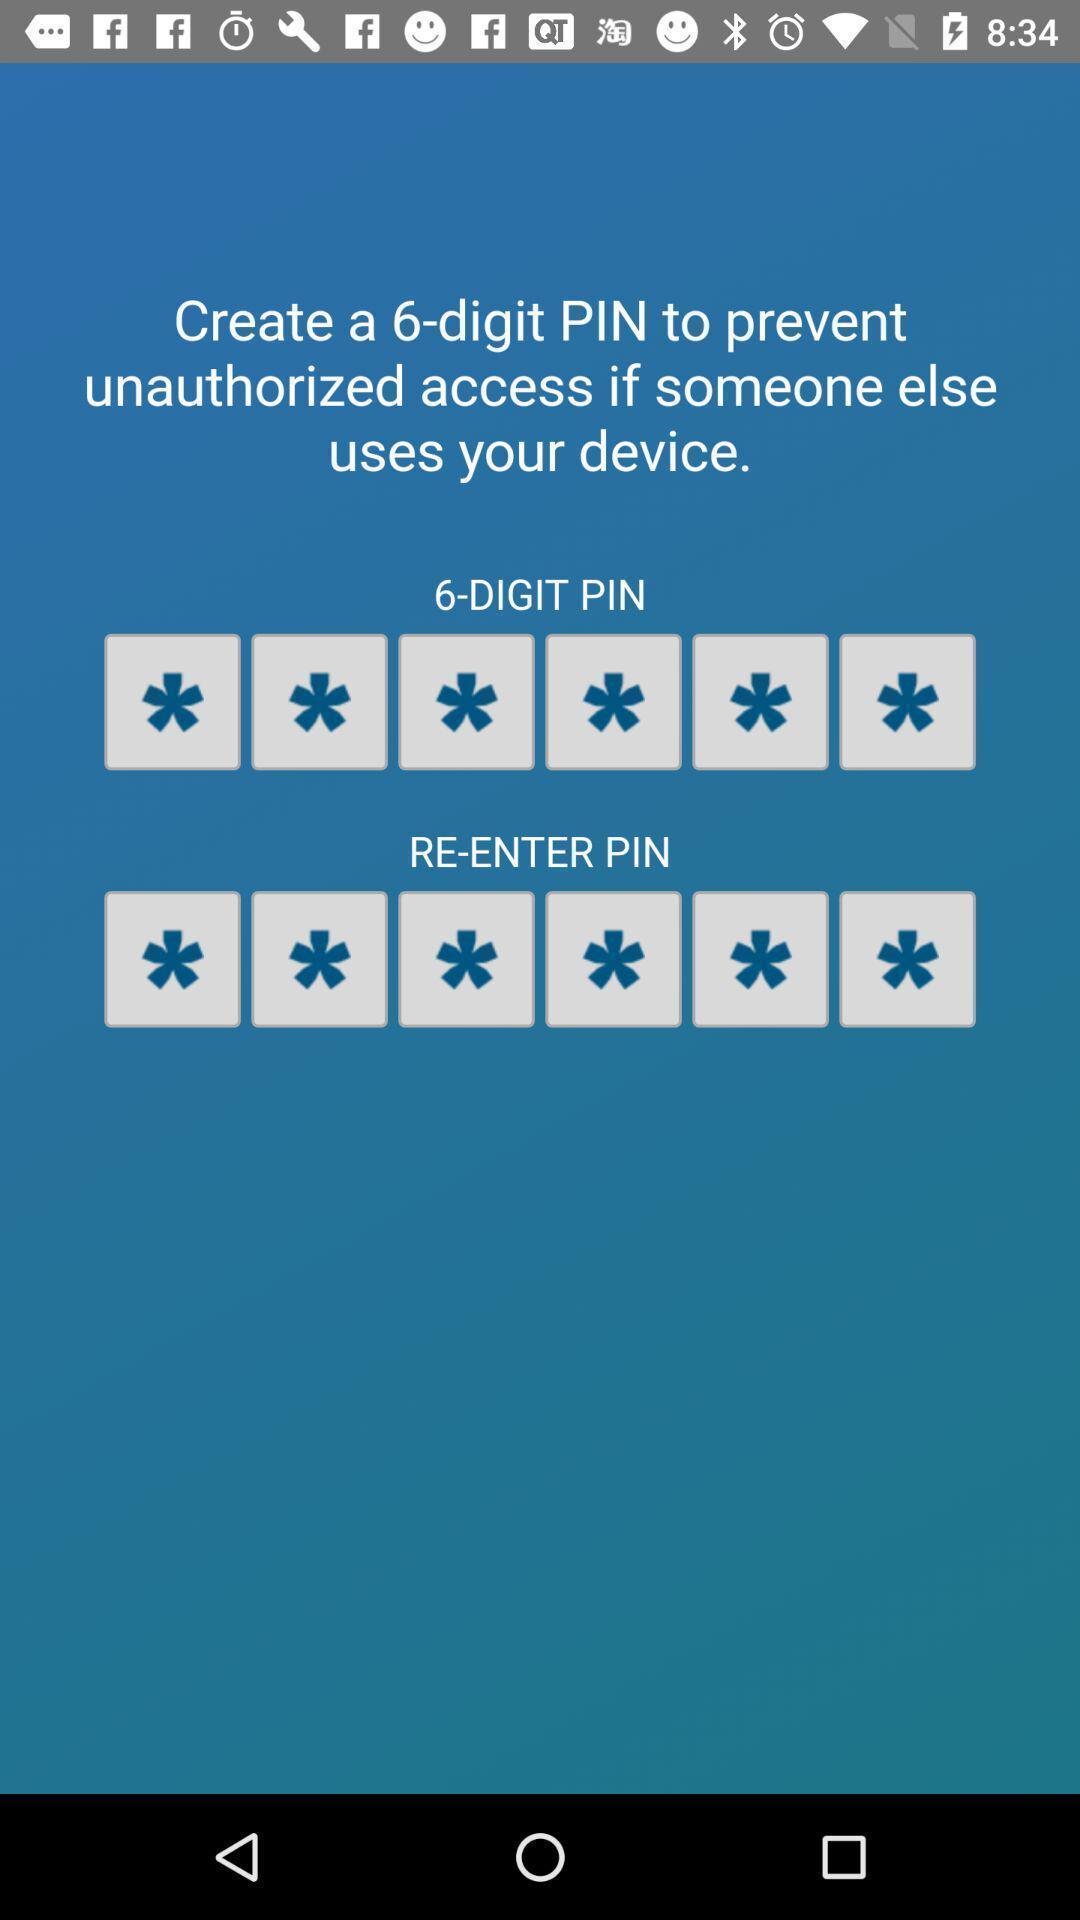Explain what's happening in this screen capture. Screen shows create pin details. 